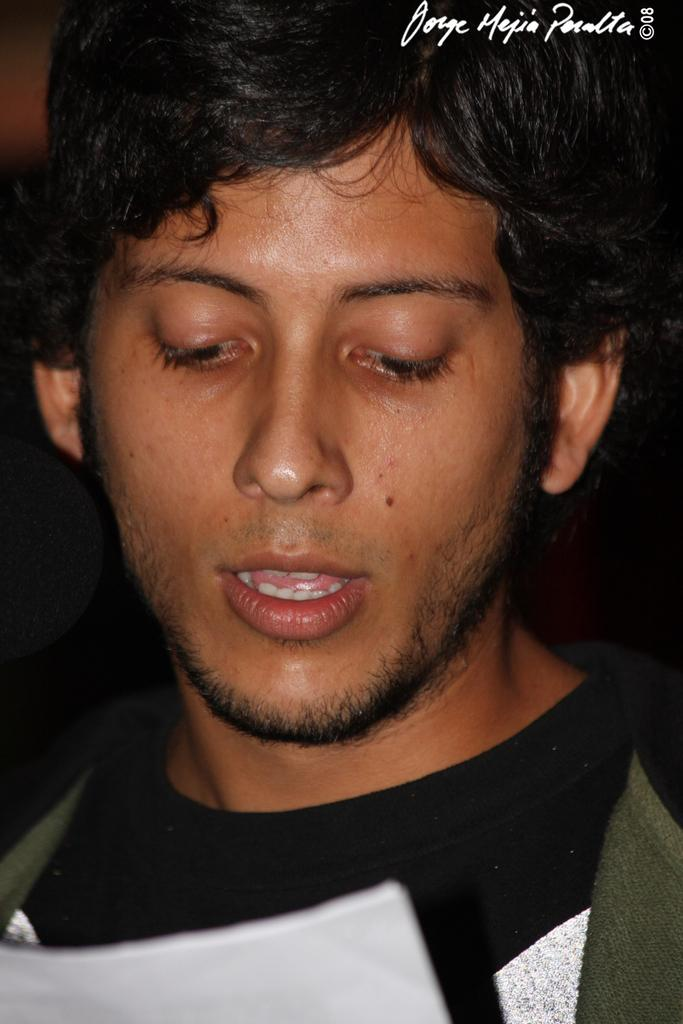What is present in the image? There is a person in the image. Can you describe the person's attire? The person is wearing clothes. Where is the text located in the image? The text is in the top right of the image. What is the name of the person's brother in the image? There is no mention of a brother or any other family members in the image. 